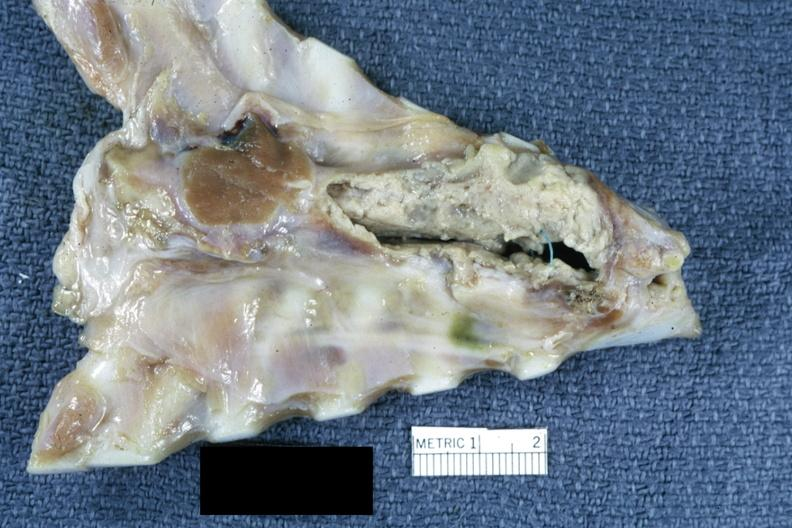s thorax, mediastinum present?
Answer the question using a single word or phrase. Yes 